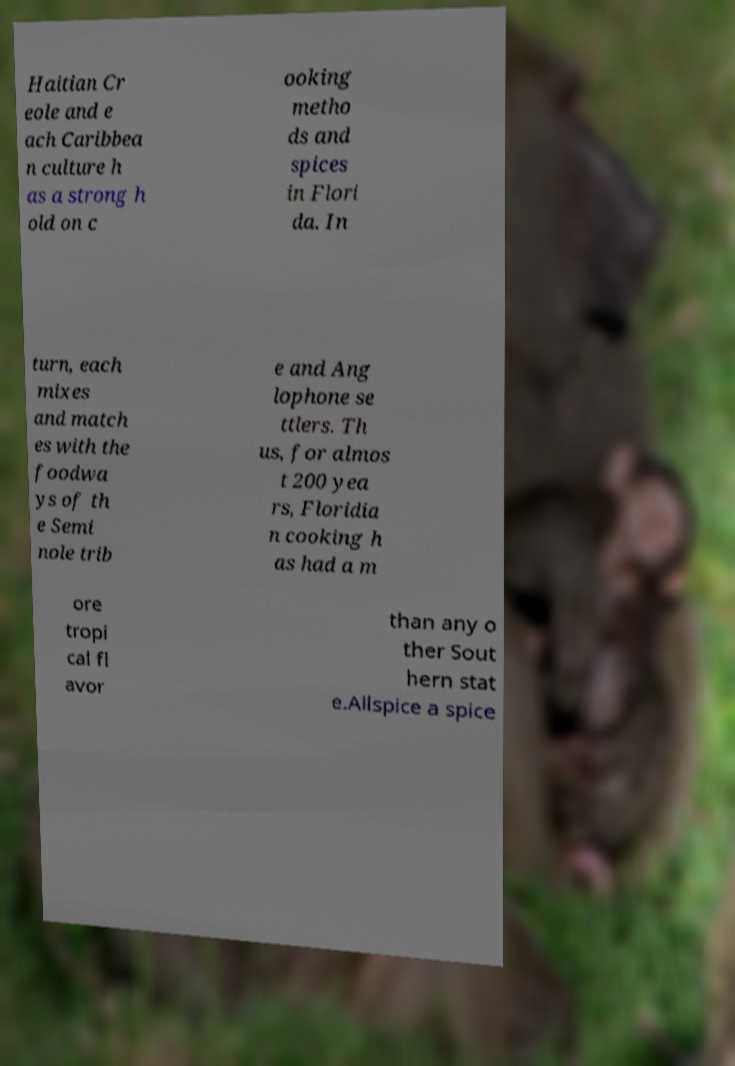Could you extract and type out the text from this image? Haitian Cr eole and e ach Caribbea n culture h as a strong h old on c ooking metho ds and spices in Flori da. In turn, each mixes and match es with the foodwa ys of th e Semi nole trib e and Ang lophone se ttlers. Th us, for almos t 200 yea rs, Floridia n cooking h as had a m ore tropi cal fl avor than any o ther Sout hern stat e.Allspice a spice 